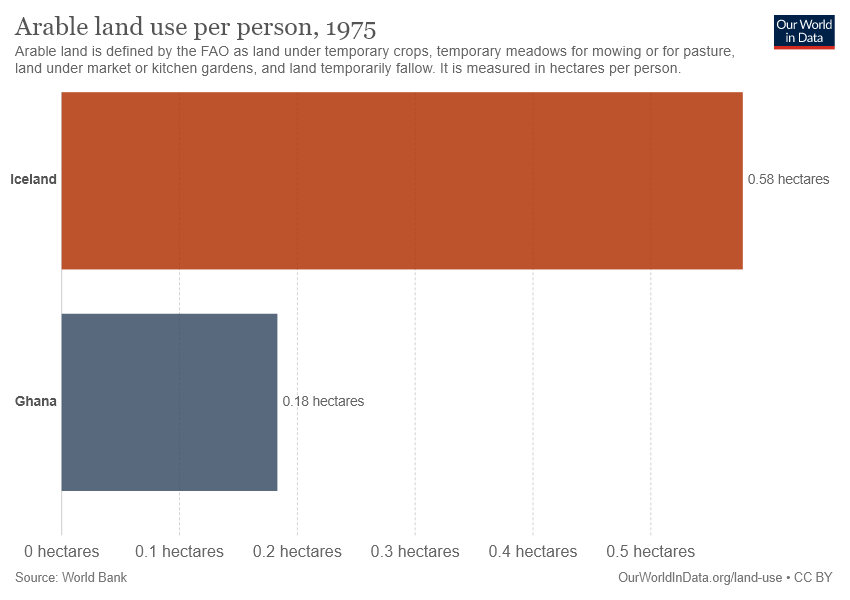Mention a couple of crucial points in this snapshot. There are two bars in the graph. The value of the largest bar is not three times the value of the smallest bar. 